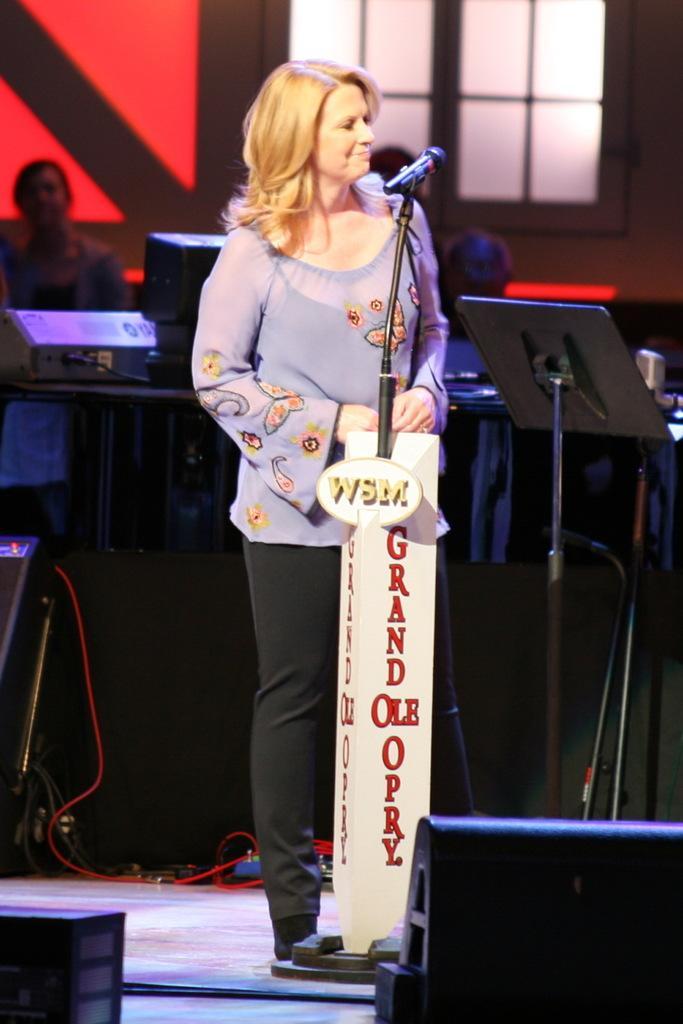Describe this image in one or two sentences. In the picture we can see a woman standing near the microphone and singing and in the background, we can see some musical instruments and some people sitting near it and behind them we can see a wall with a window. 